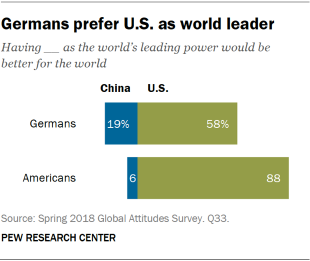Point out several critical features in this image. The average of the green bar is 54, which is 10 less than the highest value of the blue bar. The smallest blue bar has a value of 6. 